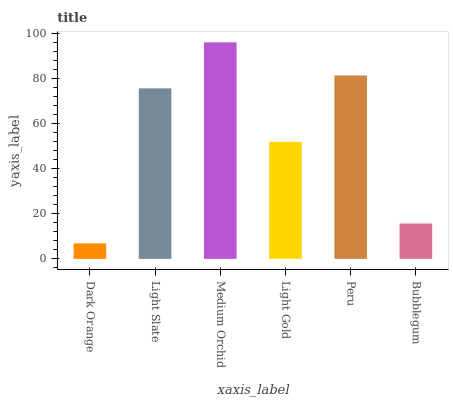Is Dark Orange the minimum?
Answer yes or no. Yes. Is Medium Orchid the maximum?
Answer yes or no. Yes. Is Light Slate the minimum?
Answer yes or no. No. Is Light Slate the maximum?
Answer yes or no. No. Is Light Slate greater than Dark Orange?
Answer yes or no. Yes. Is Dark Orange less than Light Slate?
Answer yes or no. Yes. Is Dark Orange greater than Light Slate?
Answer yes or no. No. Is Light Slate less than Dark Orange?
Answer yes or no. No. Is Light Slate the high median?
Answer yes or no. Yes. Is Light Gold the low median?
Answer yes or no. Yes. Is Medium Orchid the high median?
Answer yes or no. No. Is Medium Orchid the low median?
Answer yes or no. No. 